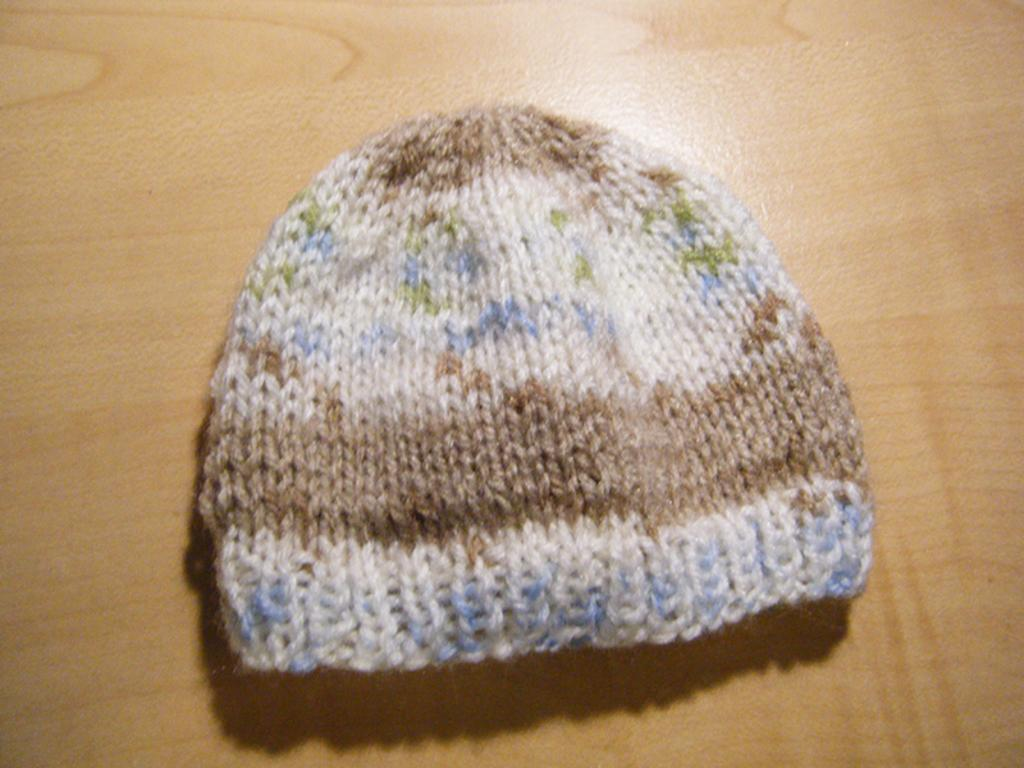What object is present in the image? There is a cap in the image. Where is the cap located? The cap is on a surface. What is the color of the surface? The surface is brown in color. What type of quiver is visible in the image? There is no quiver present in the image; it only features a cap on a brown surface. 